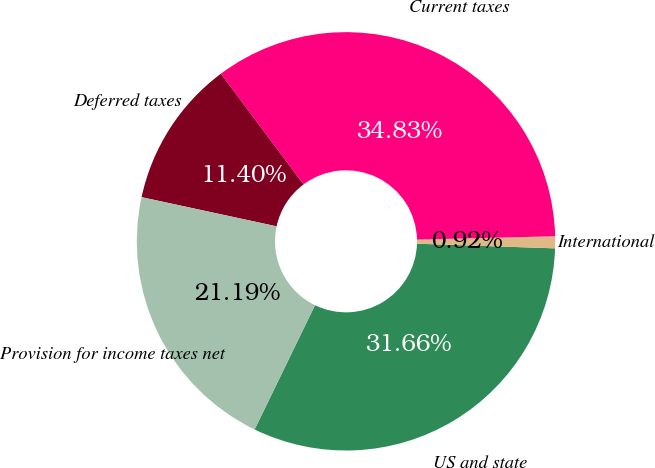Convert chart. <chart><loc_0><loc_0><loc_500><loc_500><pie_chart><fcel>US and state<fcel>International<fcel>Current taxes<fcel>Deferred taxes<fcel>Provision for income taxes net<nl><fcel>31.66%<fcel>0.92%<fcel>34.83%<fcel>11.4%<fcel>21.19%<nl></chart> 